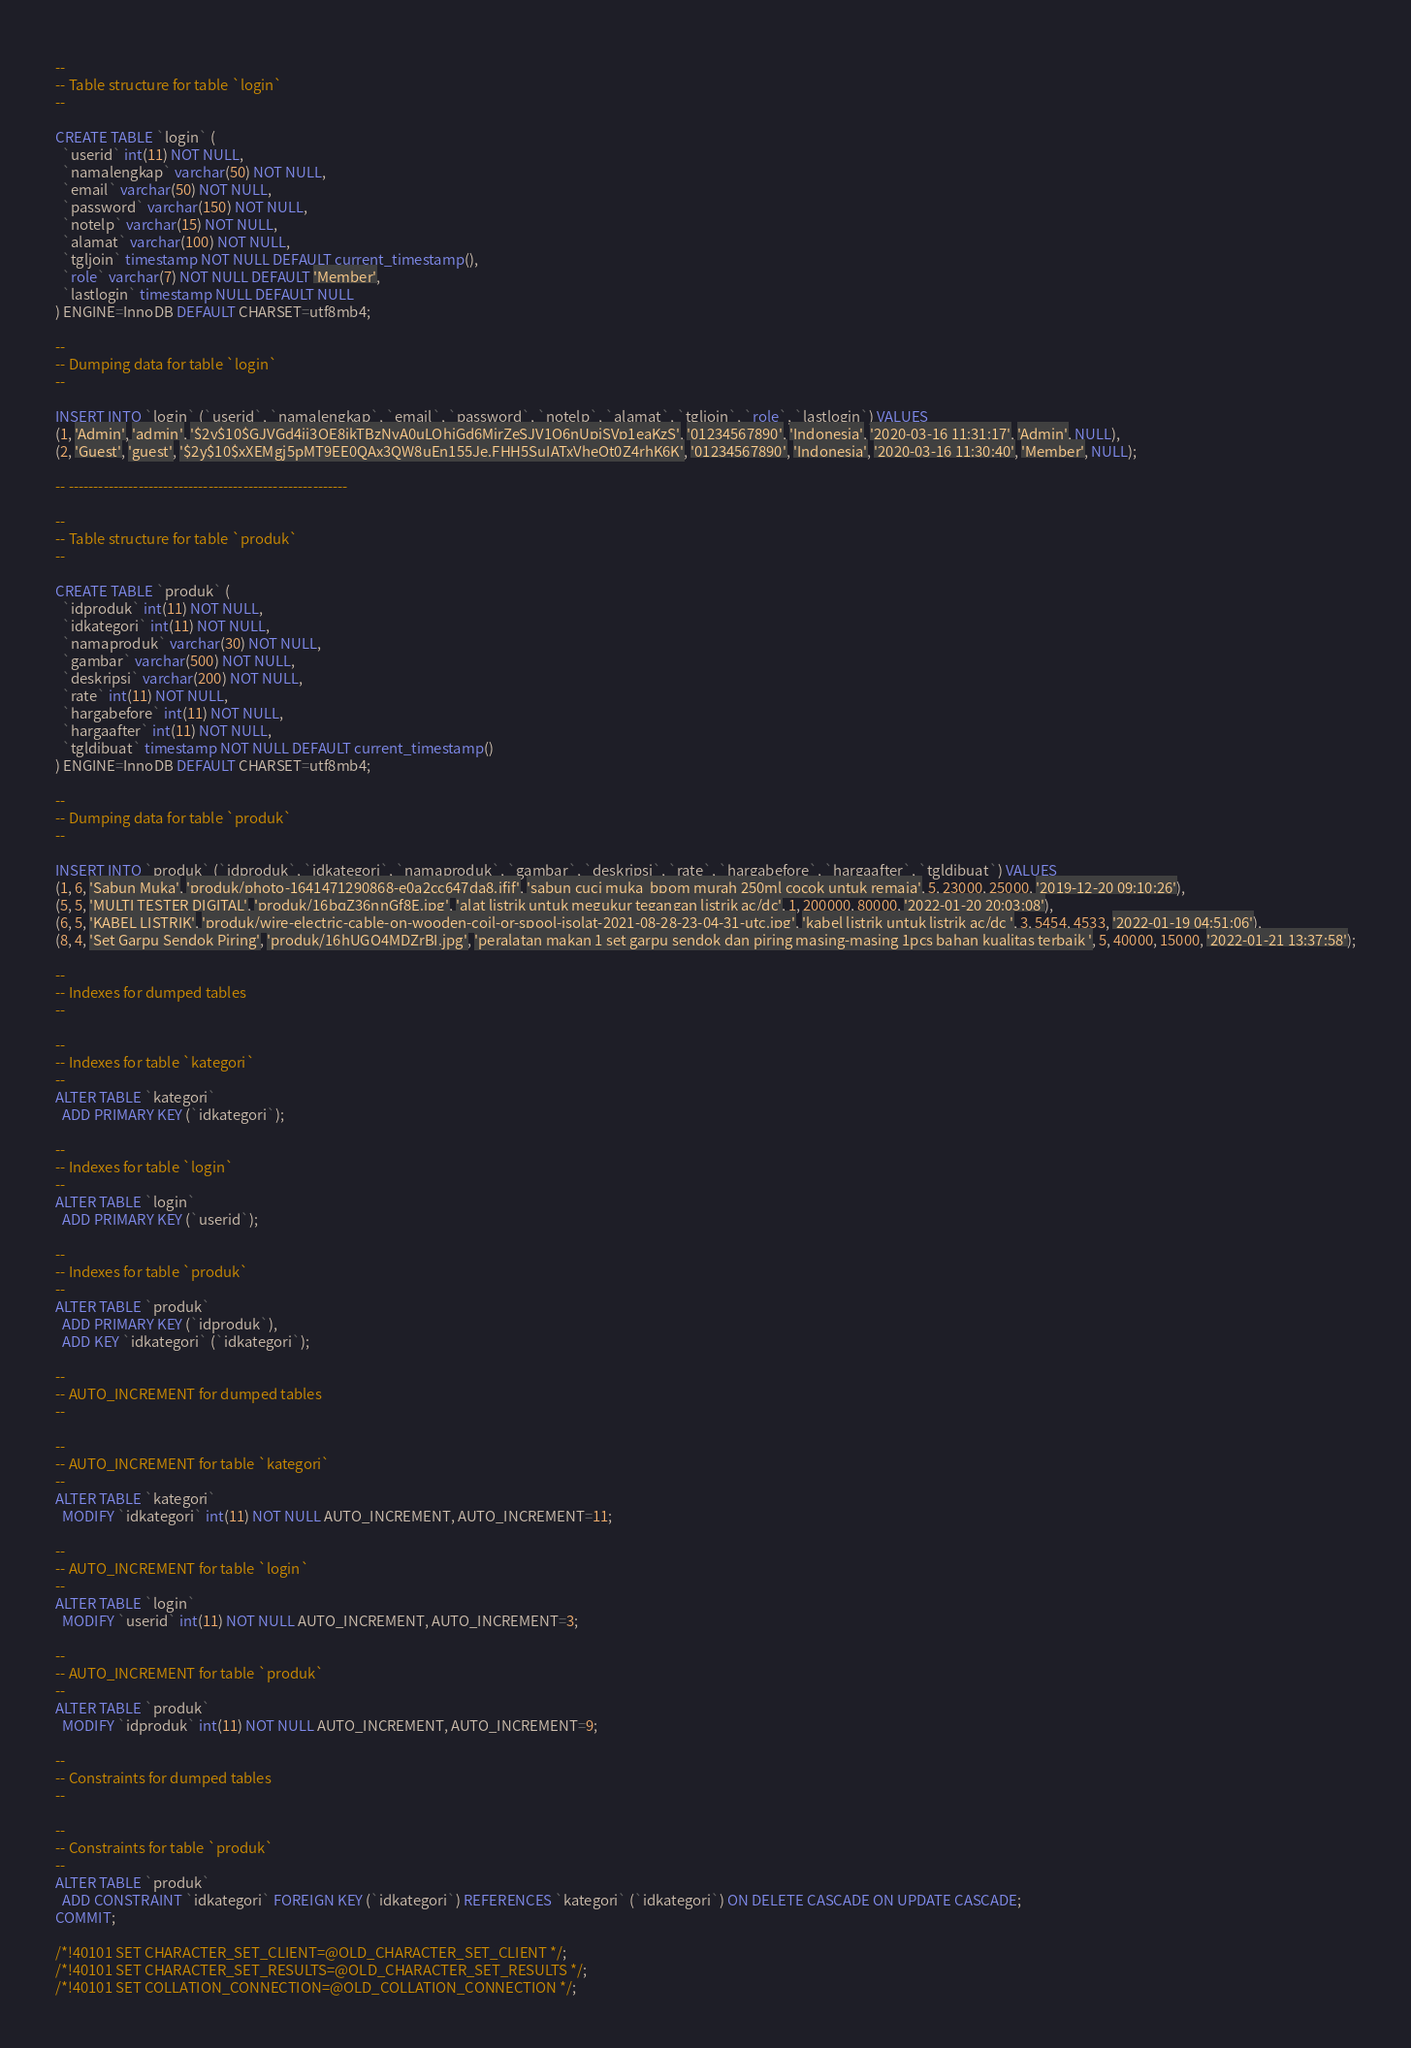<code> <loc_0><loc_0><loc_500><loc_500><_SQL_>--
-- Table structure for table `login`
--

CREATE TABLE `login` (
  `userid` int(11) NOT NULL,
  `namalengkap` varchar(50) NOT NULL,
  `email` varchar(50) NOT NULL,
  `password` varchar(150) NOT NULL,
  `notelp` varchar(15) NOT NULL,
  `alamat` varchar(100) NOT NULL,
  `tgljoin` timestamp NOT NULL DEFAULT current_timestamp(),
  `role` varchar(7) NOT NULL DEFAULT 'Member',
  `lastlogin` timestamp NULL DEFAULT NULL
) ENGINE=InnoDB DEFAULT CHARSET=utf8mb4;

--
-- Dumping data for table `login`
--

INSERT INTO `login` (`userid`, `namalengkap`, `email`, `password`, `notelp`, `alamat`, `tgljoin`, `role`, `lastlogin`) VALUES
(1, 'Admin', 'admin', '$2y$10$GJVGd4ji3QE8ikTBzNyA0uLQhiGd6MirZeSJV1O6nUpjSVp1eaKzS', '01234567890', 'Indonesia', '2020-03-16 11:31:17', 'Admin', NULL),
(2, 'Guest', 'guest', '$2y$10$xXEMgj5pMT9EE0QAx3QW8uEn155Je.FHH5SuIATxVheOt0Z4rhK6K', '01234567890', 'Indonesia', '2020-03-16 11:30:40', 'Member', NULL);

-- --------------------------------------------------------

--
-- Table structure for table `produk`
--

CREATE TABLE `produk` (
  `idproduk` int(11) NOT NULL,
  `idkategori` int(11) NOT NULL,
  `namaproduk` varchar(30) NOT NULL,
  `gambar` varchar(500) NOT NULL,
  `deskripsi` varchar(200) NOT NULL,
  `rate` int(11) NOT NULL,
  `hargabefore` int(11) NOT NULL,
  `hargaafter` int(11) NOT NULL,
  `tgldibuat` timestamp NOT NULL DEFAULT current_timestamp()
) ENGINE=InnoDB DEFAULT CHARSET=utf8mb4;

--
-- Dumping data for table `produk`
--

INSERT INTO `produk` (`idproduk`, `idkategori`, `namaproduk`, `gambar`, `deskripsi`, `rate`, `hargabefore`, `hargaafter`, `tgldibuat`) VALUES
(1, 6, 'Sabun Muka', 'produk/photo-1641471290868-e0a2cc647da8.jfif', 'sabun cuci muka  bpom murah 250ml cocok untuk remaja', 5, 23000, 25000, '2019-12-20 09:10:26'),
(5, 5, 'MULTI TESTER DIGITAL', 'produk/16bqZ36nnGf8E.jpg', 'alat listrik untuk megukur tegangan listrik ac/dc', 1, 200000, 80000, '2022-01-20 20:03:08'),
(6, 5, 'KABEL LISTRIK', 'produk/wire-electric-cable-on-wooden-coil-or-spool-isolat-2021-08-28-23-04-31-utc.jpg', 'kabel listrik untuk listrik ac/dc ', 3, 5454, 4533, '2022-01-19 04:51:06'),
(8, 4, 'Set Garpu Sendok Piring', 'produk/16hUGO4MDZrBI.jpg', 'peralatan makan 1 set garpu sendok dan piring masing-masing 1pcs bahan kualitas terbaik ', 5, 40000, 15000, '2022-01-21 13:37:58');

--
-- Indexes for dumped tables
--

--
-- Indexes for table `kategori`
--
ALTER TABLE `kategori`
  ADD PRIMARY KEY (`idkategori`);

--
-- Indexes for table `login`
--
ALTER TABLE `login`
  ADD PRIMARY KEY (`userid`);

--
-- Indexes for table `produk`
--
ALTER TABLE `produk`
  ADD PRIMARY KEY (`idproduk`),
  ADD KEY `idkategori` (`idkategori`);

--
-- AUTO_INCREMENT for dumped tables
--

--
-- AUTO_INCREMENT for table `kategori`
--
ALTER TABLE `kategori`
  MODIFY `idkategori` int(11) NOT NULL AUTO_INCREMENT, AUTO_INCREMENT=11;

--
-- AUTO_INCREMENT for table `login`
--
ALTER TABLE `login`
  MODIFY `userid` int(11) NOT NULL AUTO_INCREMENT, AUTO_INCREMENT=3;

--
-- AUTO_INCREMENT for table `produk`
--
ALTER TABLE `produk`
  MODIFY `idproduk` int(11) NOT NULL AUTO_INCREMENT, AUTO_INCREMENT=9;

--
-- Constraints for dumped tables
--

--
-- Constraints for table `produk`
--
ALTER TABLE `produk`
  ADD CONSTRAINT `idkategori` FOREIGN KEY (`idkategori`) REFERENCES `kategori` (`idkategori`) ON DELETE CASCADE ON UPDATE CASCADE;
COMMIT;

/*!40101 SET CHARACTER_SET_CLIENT=@OLD_CHARACTER_SET_CLIENT */;
/*!40101 SET CHARACTER_SET_RESULTS=@OLD_CHARACTER_SET_RESULTS */;
/*!40101 SET COLLATION_CONNECTION=@OLD_COLLATION_CONNECTION */;
</code> 